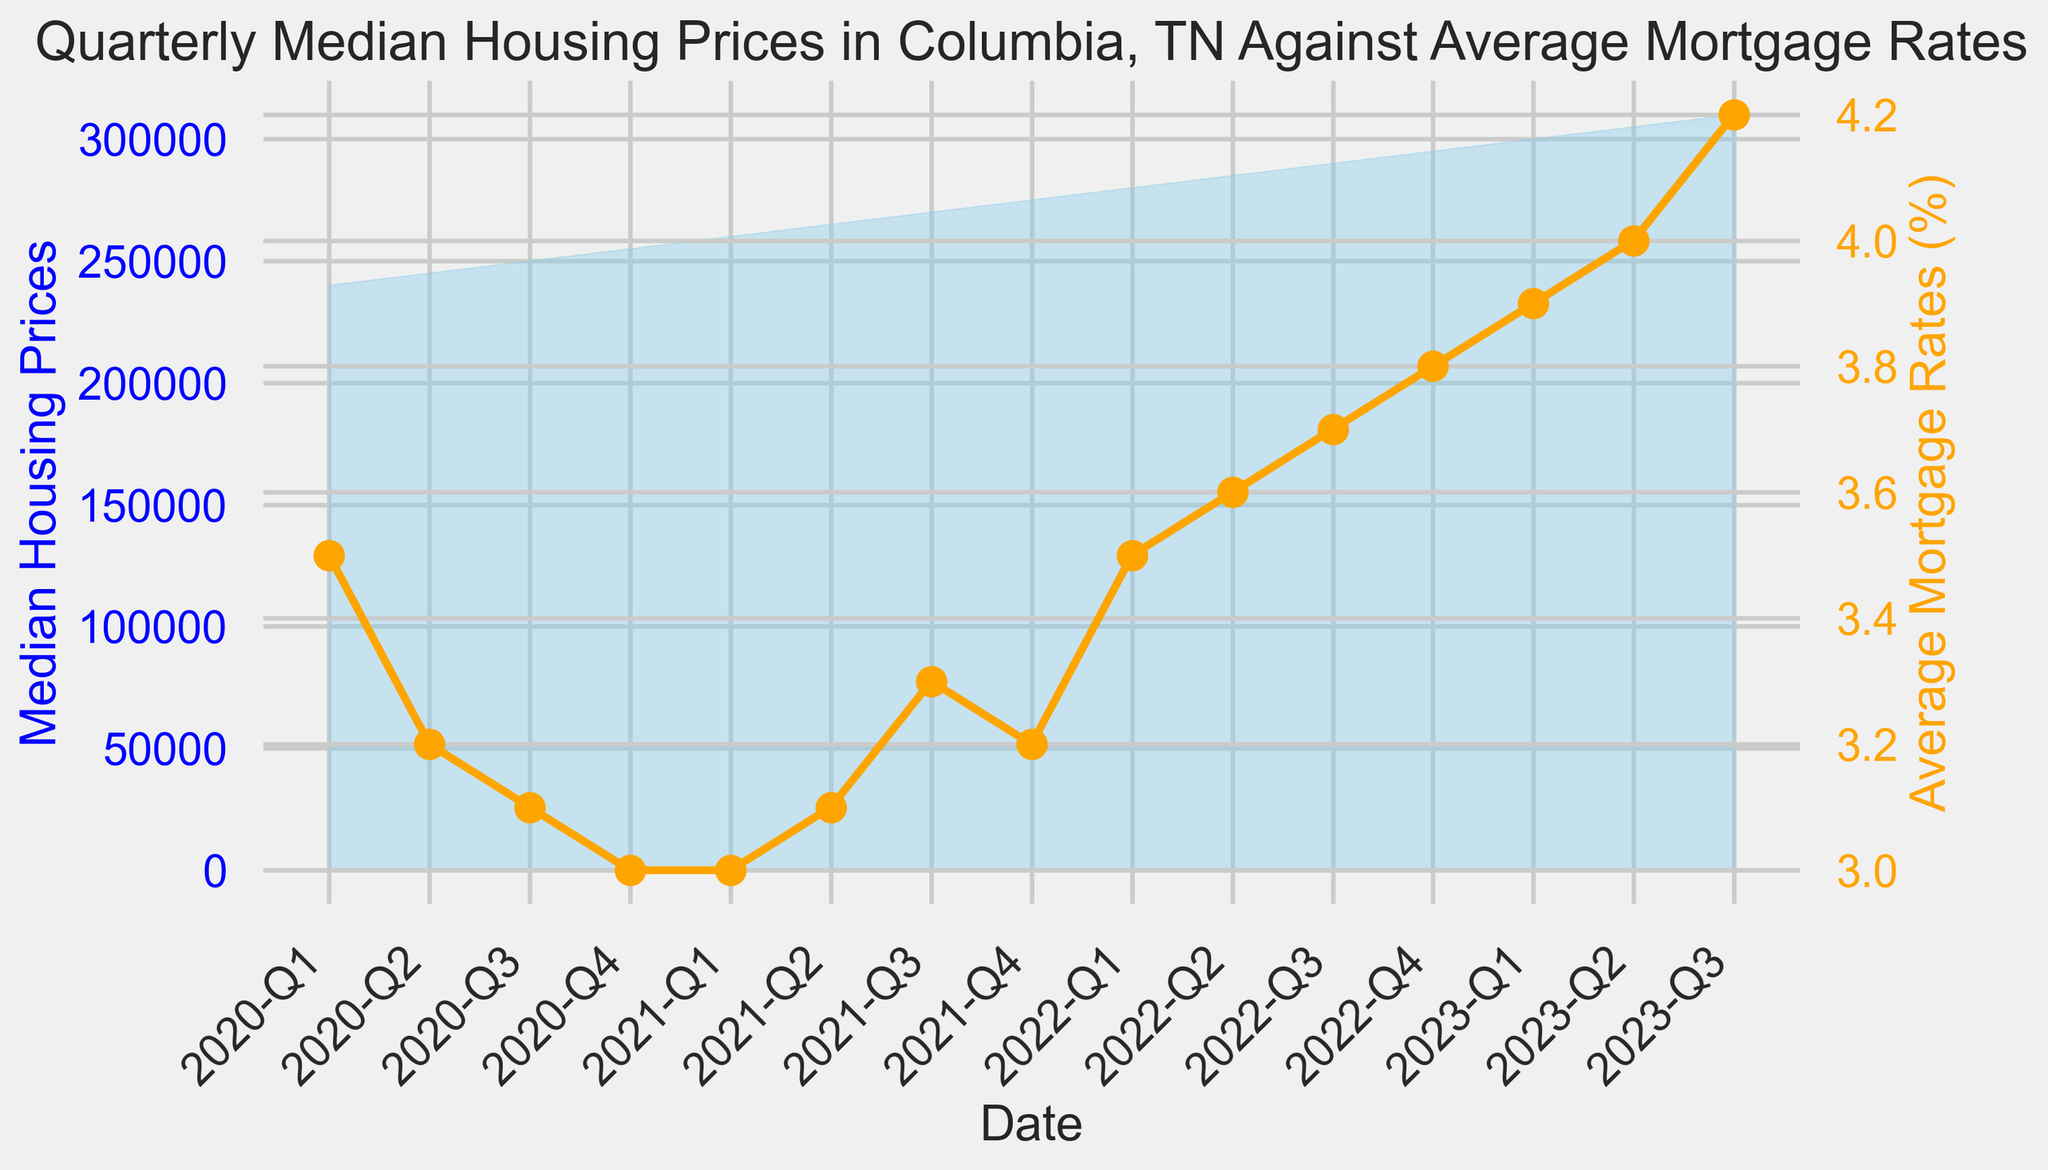What was the median housing price in 2020-Q3? First, locate the 2020-Q3 point on the Date axis. Then, look at the corresponding value on the Median Housing Prices axis.
Answer: 250000 How did the average mortgage rate change from 2020-Q1 to 2020-Q4? Identify the values of Average Mortgage Rates for both 2020-Q1 and 2020-Q4. Subtract the mortgage rate of 2020-Q1 from that of 2020-Q4 (3.0 - 3.5).
Answer: Decreased by 0.5% What is the overall trend for median housing prices from 2020-Q1 to 2023-Q3? Observe the overall movement of the area representing Median Housing Prices from 2020-Q1 to 2023-Q3. It shows a steady increase.
Answer: Increasing Which quarter saw the highest average mortgage rate? Look for the quarter where the orange line is at its highest point. This appears to be 2023-Q3.
Answer: 2023-Q3 Compare the rate of increase in median housing prices with the rate of increase in average mortgage rates from 2021-Q4 to 2023-Q3. From 2021-Q4 to 2023-Q3, Median Housing Prices increased from 275000 to 310000 (an increase of 35000) and Average Mortgage Rates increased from 3.2% to 4.2% (an increase of 1.0%).
Answer: Median housing prices increased faster What was the percentage increase in the median housing price from 2020-Q1 to 2023-Q3? Calculate the percentage increase using the formula [(final value - initial value) / initial value] * 100. For housing prices, this is [(310000 - 240000) / 240000] * 100.
Answer: 29.17% Which quarter had the smallest difference between the median housing price and the average mortgage rate? Calculate the difference for each quarter by subtracting the mortgage rate from the housing price. The quarter with the smallest result is 2021-Q1.
Answer: 2021-Q1 How does the color-coding help distinguish between median housing prices and average mortgage rates? The area under the Median Housing Prices curve is filled with skyblue, whereas the Average Mortgage Rates are plotted as an orange line. This visual distinction helps in easily differentiating between the two data sets.
Answer: Different colors (skyblue and orange) Between which two consecutive quarters did the median housing prices show the largest increase? Calculate the difference in Median Housing Prices for each pair of consecutive quarters. The largest increase is between 2022-Q3 and 2022-Q4 (295000 - 290000).
Answer: 2022-Q3 to 2022-Q4 